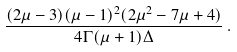Convert formula to latex. <formula><loc_0><loc_0><loc_500><loc_500>\frac { ( 2 \mu - 3 ) ( \mu - 1 ) ^ { 2 } ( 2 \mu ^ { 2 } - 7 \mu + 4 ) } { 4 \Gamma ( \mu + 1 ) \Delta } \, .</formula> 